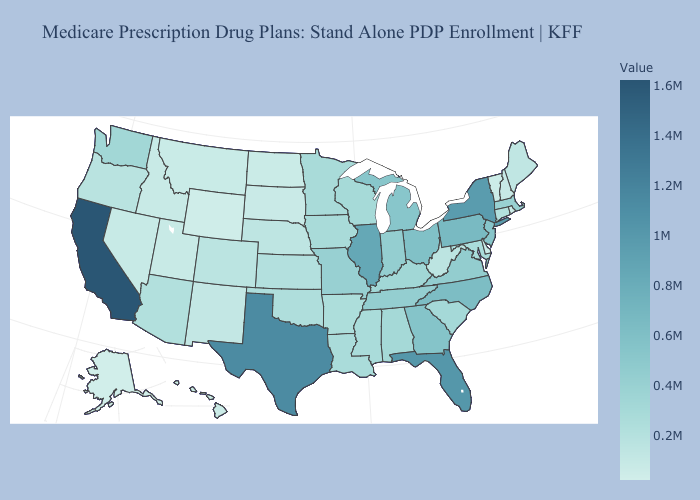Which states have the lowest value in the MidWest?
Give a very brief answer. North Dakota. Among the states that border Nevada , which have the highest value?
Quick response, please. California. Does Massachusetts have the lowest value in the Northeast?
Answer briefly. No. Does Oregon have a higher value than Pennsylvania?
Quick response, please. No. Does Alaska have the lowest value in the USA?
Keep it brief. Yes. Among the states that border Vermont , does New York have the lowest value?
Short answer required. No. Among the states that border Tennessee , which have the highest value?
Concise answer only. North Carolina. Among the states that border New Hampshire , does Massachusetts have the lowest value?
Quick response, please. No. 